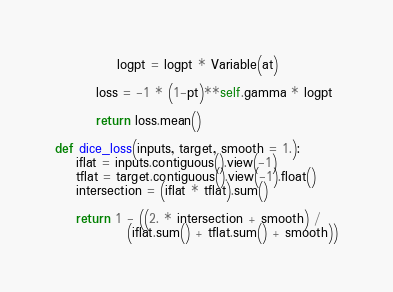<code> <loc_0><loc_0><loc_500><loc_500><_Python_>            logpt = logpt * Variable(at)

        loss = -1 * (1-pt)**self.gamma * logpt
        
        return loss.mean()
    
def dice_loss(inputs, target, smooth = 1.):
    iflat = inputs.contiguous().view(-1)
    tflat = target.contiguous().view(-1).float()
    intersection = (iflat * tflat).sum()
    
    return 1 - ((2. * intersection + smooth) /
              (iflat.sum() + tflat.sum() + smooth))</code> 